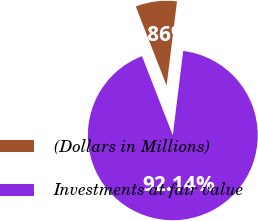Convert chart to OTSL. <chart><loc_0><loc_0><loc_500><loc_500><pie_chart><fcel>(Dollars in Millions)<fcel>Investments at fair value<nl><fcel>7.86%<fcel>92.14%<nl></chart> 